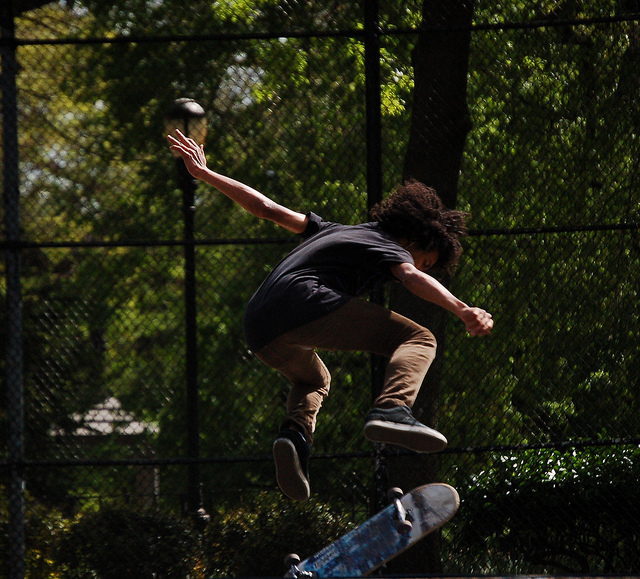<image>What is that white disk? There is no white disk in the image. It might be a skateboard. What is that white disk? I am not sure what that white disk is. It can be a skateboard. 